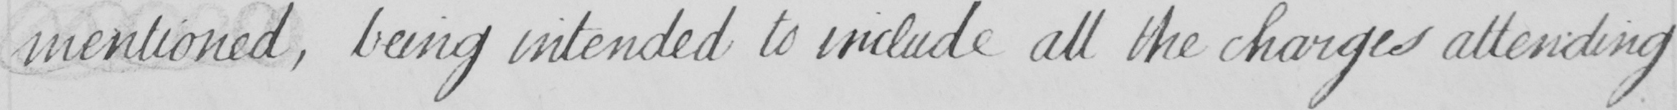What is written in this line of handwriting? mentioned , being intended to include all the charges attending 